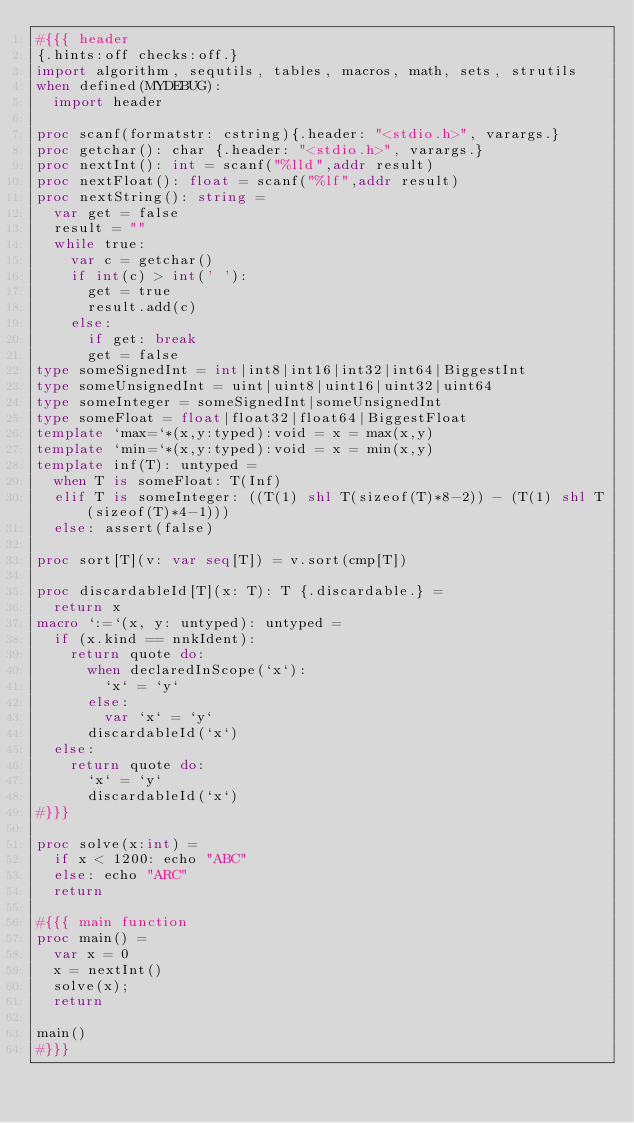<code> <loc_0><loc_0><loc_500><loc_500><_Nim_>#{{{ header
{.hints:off checks:off.}
import algorithm, sequtils, tables, macros, math, sets, strutils
when defined(MYDEBUG):
  import header

proc scanf(formatstr: cstring){.header: "<stdio.h>", varargs.}
proc getchar(): char {.header: "<stdio.h>", varargs.}
proc nextInt(): int = scanf("%lld",addr result)
proc nextFloat(): float = scanf("%lf",addr result)
proc nextString(): string =
  var get = false
  result = ""
  while true:
    var c = getchar()
    if int(c) > int(' '):
      get = true
      result.add(c)
    else:
      if get: break
      get = false
type someSignedInt = int|int8|int16|int32|int64|BiggestInt
type someUnsignedInt = uint|uint8|uint16|uint32|uint64
type someInteger = someSignedInt|someUnsignedInt
type someFloat = float|float32|float64|BiggestFloat
template `max=`*(x,y:typed):void = x = max(x,y)
template `min=`*(x,y:typed):void = x = min(x,y)
template inf(T): untyped = 
  when T is someFloat: T(Inf)
  elif T is someInteger: ((T(1) shl T(sizeof(T)*8-2)) - (T(1) shl T(sizeof(T)*4-1)))
  else: assert(false)

proc sort[T](v: var seq[T]) = v.sort(cmp[T])

proc discardableId[T](x: T): T {.discardable.} =
  return x
macro `:=`(x, y: untyped): untyped =
  if (x.kind == nnkIdent):
    return quote do:
      when declaredInScope(`x`):
        `x` = `y`
      else:
        var `x` = `y`
      discardableId(`x`)
  else:
    return quote do:
      `x` = `y`
      discardableId(`x`)
#}}}

proc solve(x:int) =
  if x < 1200: echo "ABC"
  else: echo "ARC"
  return

#{{{ main function
proc main() =
  var x = 0
  x = nextInt()
  solve(x);
  return

main()
#}}}
</code> 